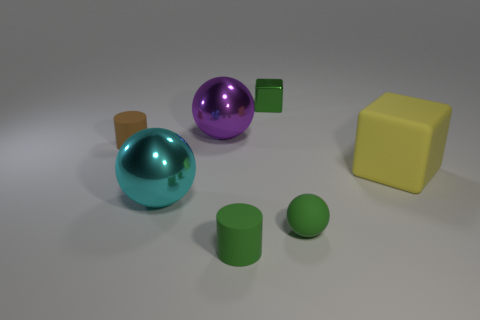Are there more rubber spheres in front of the green cube than tiny blue matte objects? Indeed, there are more rubber spheres visible in the foreground than tiny blue matte objects. Specifically, there are two rubber spheres, whereas we can see only one small blue matte object. Observing their properties, the rubber spheres have a shiny, reflective surface, suggesting a different material composition compared to the matte finish of the blue object. 